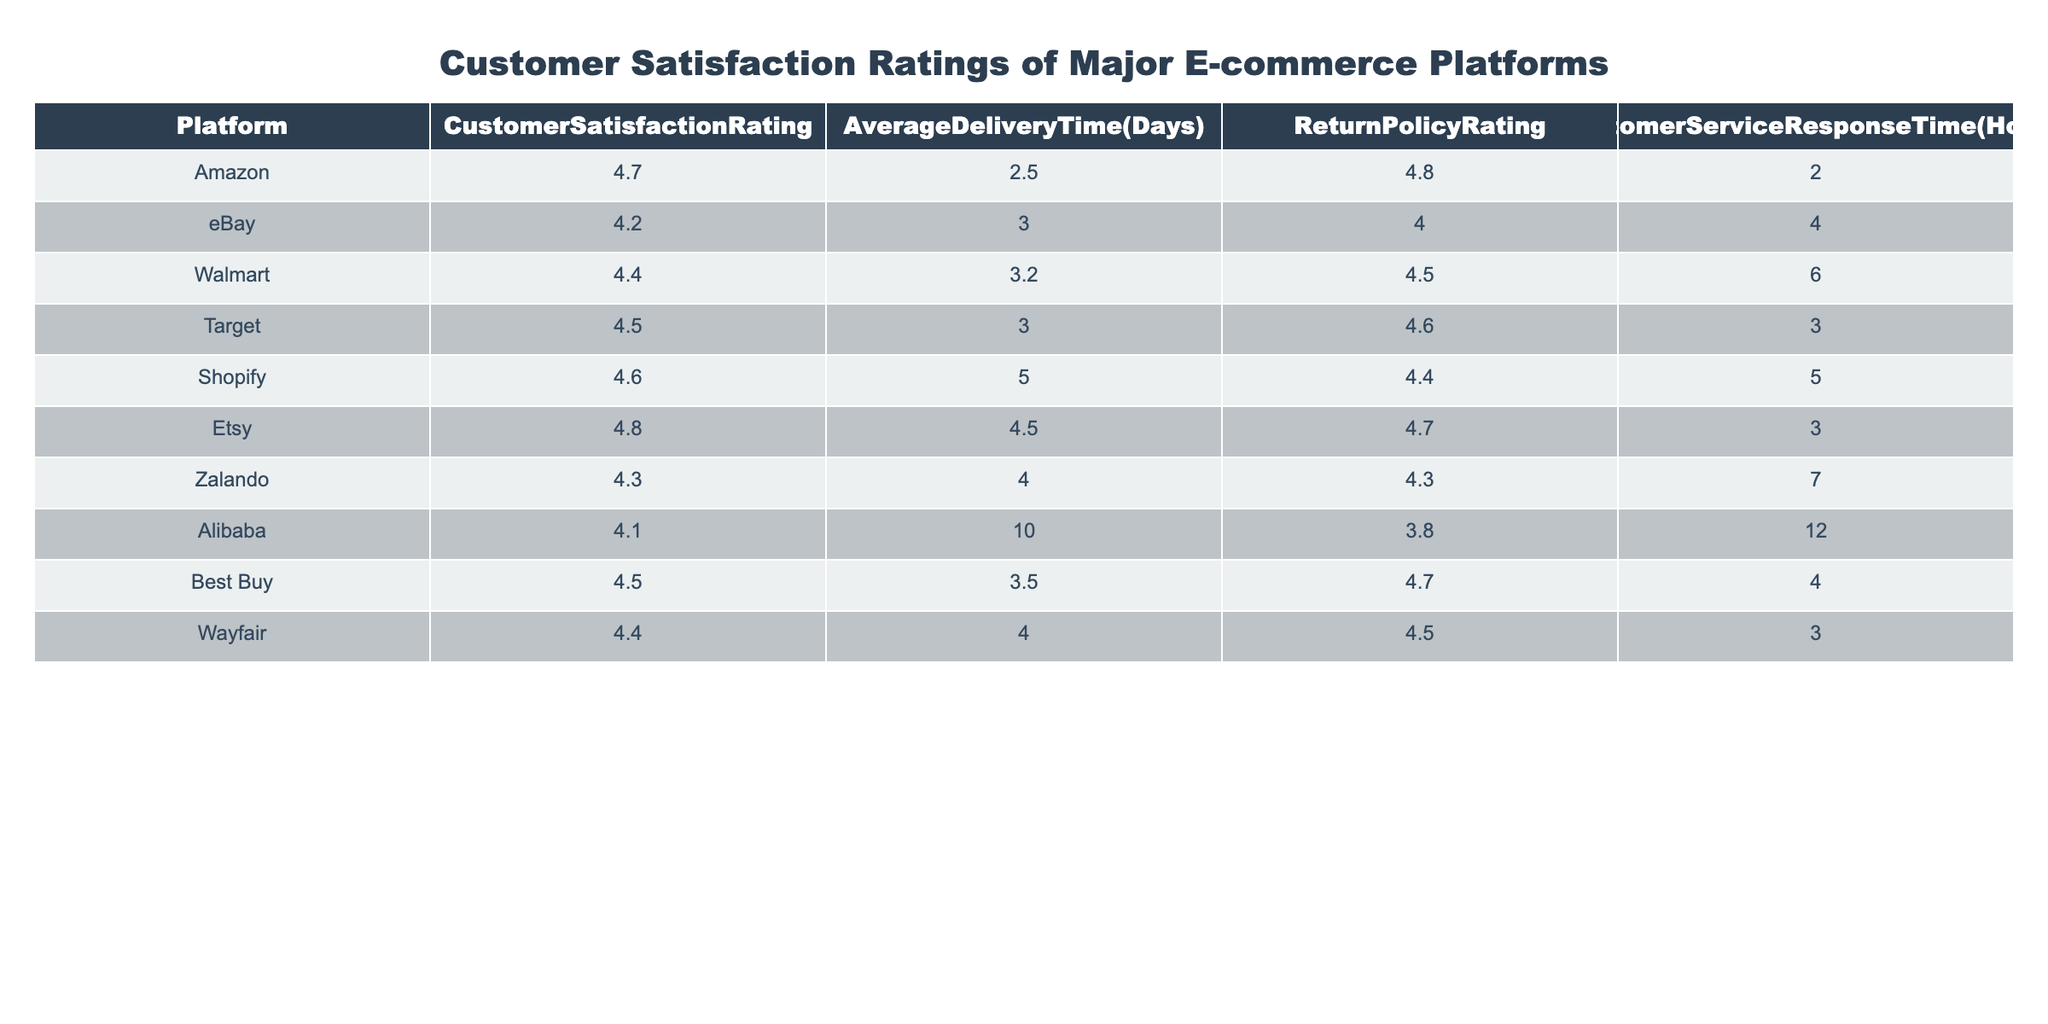What is the customer satisfaction rating for Etsy? By looking at the table, we can find the row corresponding to Etsy and refer to the Customer Satisfaction Rating column, which shows a value of 4.8.
Answer: 4.8 Which platform has the shortest average delivery time? The Average Delivery Time column must be examined, and the values are compared. The shortest delivery time is seen with Amazon at 2.5 days.
Answer: Amazon What is the average customer satisfaction rating across all platforms? To find the average, we sum the Customer Satisfaction Ratings (4.7 + 4.2 + 4.4 + 4.5 + 4.6 + 4.8 + 4.3 + 4.1 + 4.5 + 4.4 = 44.5) and then divide by the number of platforms (10). Thus, the average is 4.45.
Answer: 4.45 Is it true that Walmart has a customer satisfaction rating higher than eBay? By comparing the two ratings directly from the table, Walmart has a rating of 4.4 and eBay has a rating of 4.2. Thus, Walmart’s rating is higher.
Answer: Yes Which platform has the longest delivery time and what is that time? The Average Delivery Time column is analyzed, and the value for Alibaba at 10.0 days is identified as the longest delivery time.
Answer: Alibaba, 10.0 days Which platform has the best return policy rating while also having a customer satisfaction rating above 4.5? The table is examined for platforms with ratings above 4.5; they are Amazon (4.8),Target (4.6), Shopify (4.4), and Etsy (4.7). Among these, the return policy ratings are found, Amazon has 4.8 and Target has 4.6. Thus, Amazon has the best return policy rating of 4.8 while maintaining a customer satisfaction rating above 4.5.
Answer: Amazon, 4.8 Does any platform have a customer service response time of less than 3 hours? Checking the Customer Service Response Time column, all platforms are compared. Every platform shows response times of 2 hours, 4 hours, 6 hours, 5 hours, 3 hours, and 12 hours. Therefore, it can be concluded that yes, Amazon does have a customer service response time of 2 hours which is less than 3 hours.
Answer: Yes What is the difference in customer satisfaction ratings between the platform with the highest and lowest ratings? The maximum customer satisfaction rating is found for Etsy at 4.8 and the minimum for Alibaba at 4.1. The difference calculated is 4.8 - 4.1 = 0.7.
Answer: 0.7 Identify the platform with the second-best customer satisfaction rating and provide its return policy rating. First, the customer satisfaction ratings are sorted in descending order. The highest is Etsy at 4.8, and the second is Amazon at 4.7. The return policy rating for Amazon is then checked and found to be 4.8.
Answer: Amazon, 4.8 